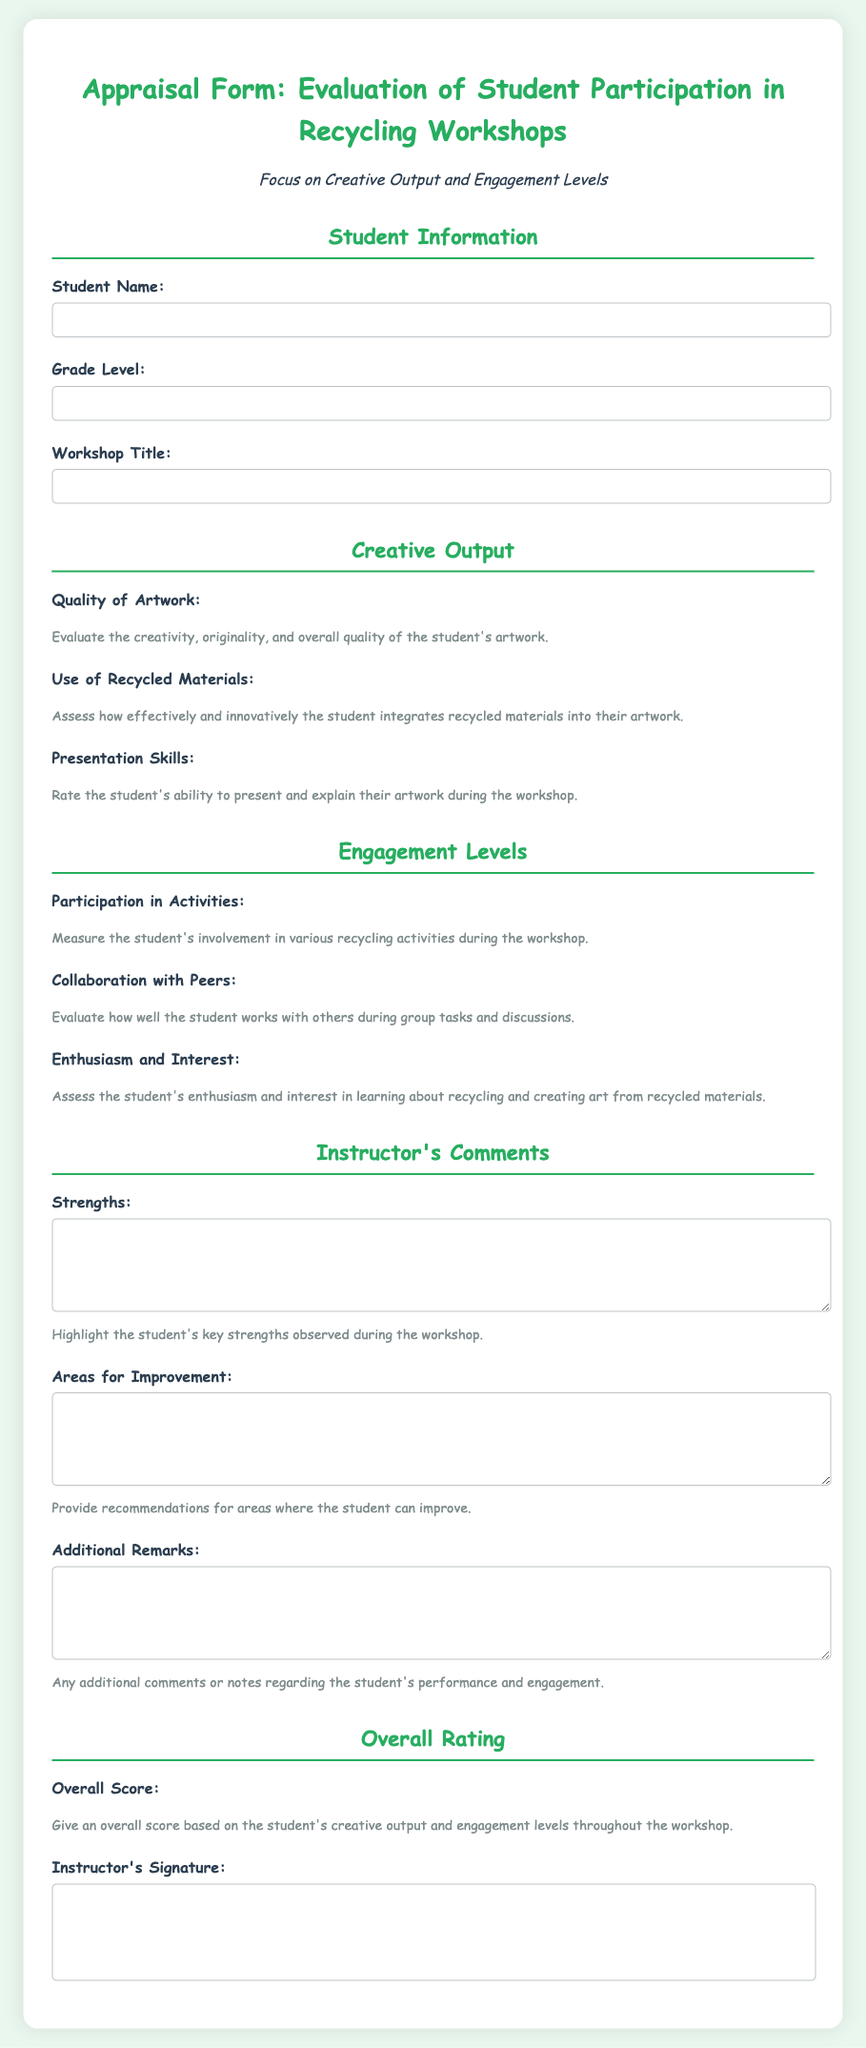What is the title of the workshop? The title of the workshop can be found in the "Workshop Title" section of the document.
Answer: Workshop Title What is the quality rating scale for artwork? The quality of artwork is rated using a scale from 1 to 5 stars, as indicated in the rating section.
Answer: 1 to 5 How many areas of creative output are evaluated in the form? The form has three areas of creative output that are evaluated, which are quality of artwork, use of recycled materials, and presentation skills.
Answer: Three What criteria is used to assess enthusiasm and interest? Enthusiasm and interest are assessed based on a rating scale from 1 to 5 in the engagement levels section.
Answer: Rating scale What type of feedback is requested in the strengths section? The strengths section requests observations regarding the student's key strengths during the workshop.
Answer: Key strengths What aspect of collaboration is evaluated in the form? The evaluation focuses on how well the student works with others during group tasks and discussions.
Answer: Group tasks and discussions What element must the instructor provide at the end of the form? The instructor must provide their signature at the end of the form, indicating their approval.
Answer: Instructor's Signature How is the overall score determined? The overall score is determined based on the student's creative output and engagement levels throughout the workshop.
Answer: Creative output and engagement levels 